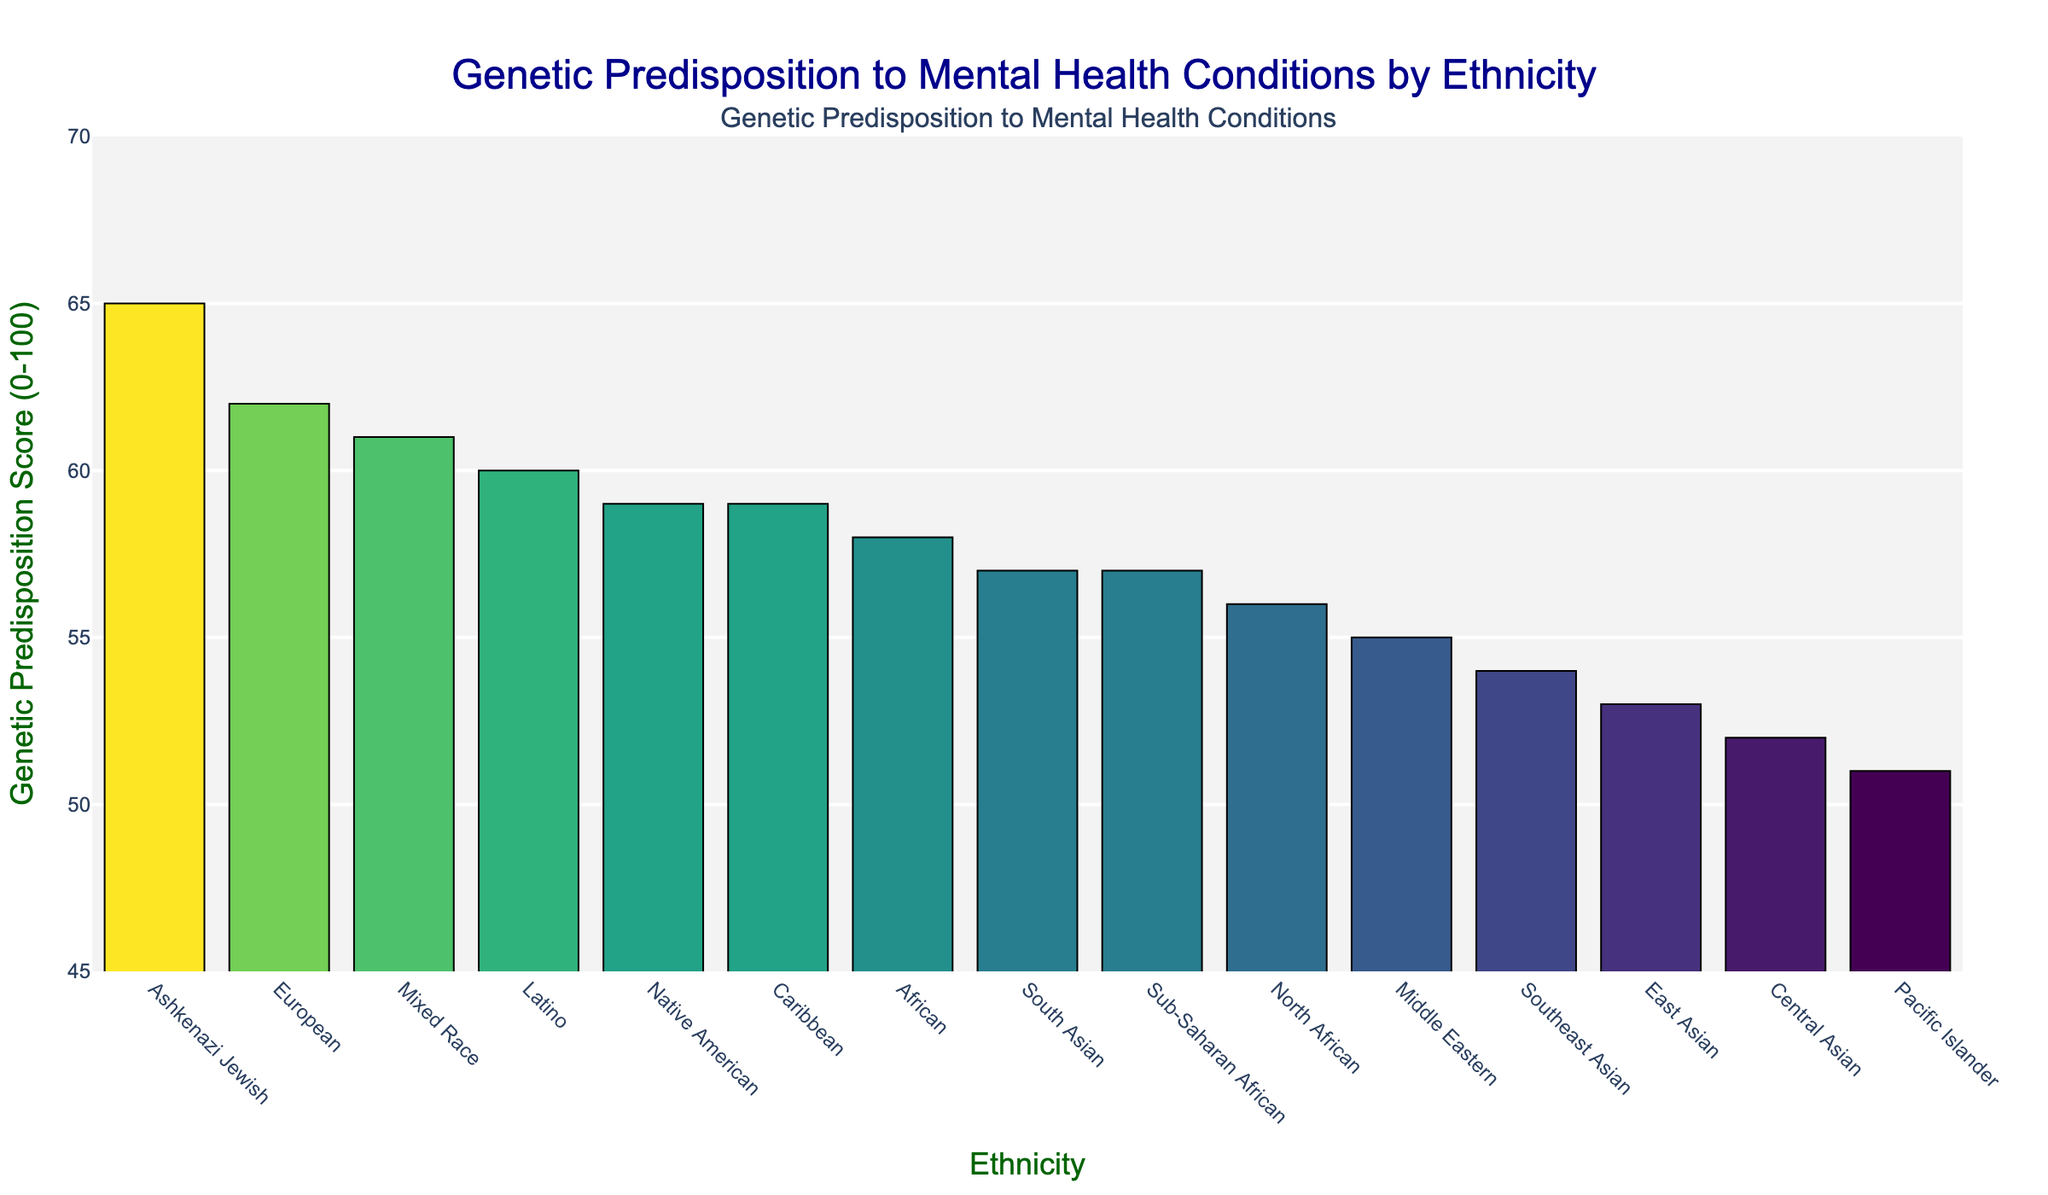Which ethnicity has the highest Genetic Predisposition Score? The ethnicity with the highest bar in the chart represents the highest Genetic Predisposition Score. By observing the chart, the Ashkenazi Jewish ethnicity has the tallest bar.
Answer: Ashkenazi Jewish How does the Genetic Predisposition Score of East Asians compare to that of Latinos? East Asians have a bar with a score of 53, while Latinos' bar has a score of 60. By comparing the heights of the bars, it is apparent that the Latino group has a higher score than the East Asian group.
Answer: Latinos have a higher score What is the average Genetic Predisposition Score across all ethnicities? Add the scores for all ethnicities and then divide by the number of ethnicities to find the average. (62 + 58 + 53 + 57 + 60 + 55 + 59 + 51 + 54 + 61 + 65 + 56 + 52 + 59 + 57) / 15 = 56.6
Answer: 56.6 Which ethnicities have a Genetic Predisposition Score greater than 60? Identify the bars that have heights greater than 60. By looking at the chart, the ethnicities are Ashkenazi Jewish (65), Mixed Race (61), and European (62).
Answer: Ashkenazi Jewish, Mixed Race, European What is the difference in Genetic Predisposition Score between the highest and the lowest ethnicities? The highest score is for Ashkenazi Jewish at 65, and the lowest score is for Pacific Islander at 51. Subtracting the smallest from the largest gives 65 - 51 = 14.
Answer: 14 Which are the top three ethnicities with the highest Genetic Predisposition Scores? The top three ethnicities can be identified by finding the three tallest bars. These are Ashkenazi Jewish (65), European (62), and Mixed Race (61).
Answer: Ashkenazi Jewish, European, Mixed Race How does the Genetic Predisposition Score for Central Asians compare to that of South Asians? Central Asians have a score of 52, while South Asians have a score of 57. By comparing the heights of their bars, South Asians have a higher score.
Answer: South Asians have a higher score What is the median Genetic Predisposition Score among the ethnicities? Arrange the scores in ascending order and find the middle value. The scores in order are: 51, 52, 53, 54, 55, 56, 57, 57, 58, 59, 59, 60, 61, 62, 65. The median value in this list is 57.
Answer: 57 Do Native Americans and Caribbeans have the same Genetic Predisposition Score? By looking at the heights of the bars, both Native Americans and Caribbeans have a score of 59.
Answer: Yes What color represents the highest Genetic Predisposition Score on the chart? The highest score is represented by Ashkenazi Jewish with a score of 65. According to the Viridis color scale used, this bar will have the brightest or most intense color towards the yellow-green end of the scale.
Answer: A bright yellow-green color 